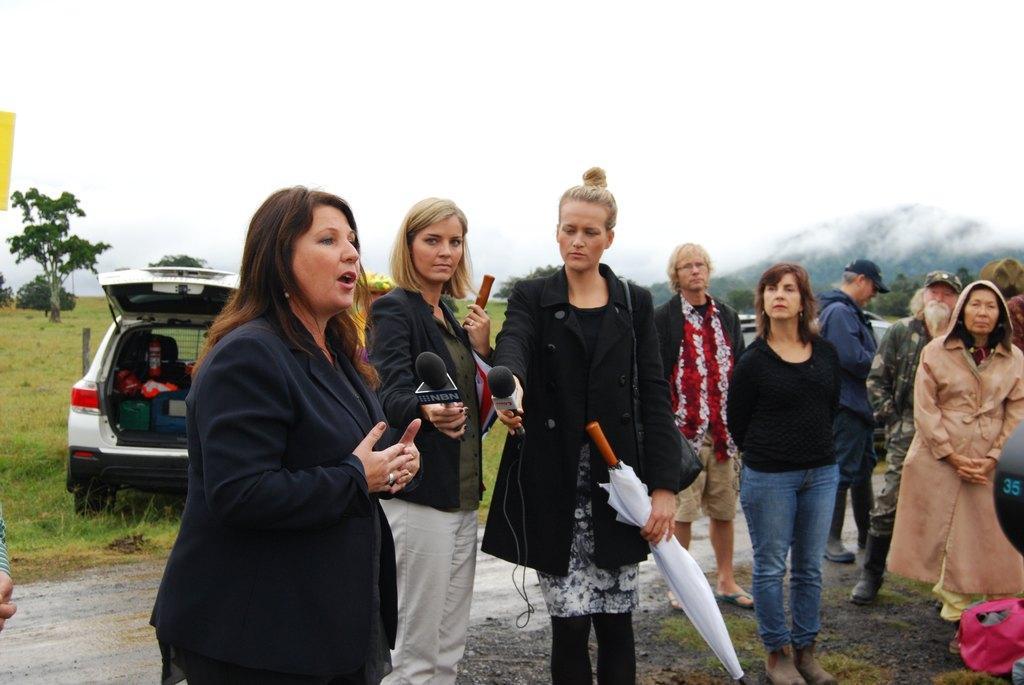In one or two sentences, can you explain what this image depicts? In this picture we can see a group of people on the ground, one woman is holding an umbrella, mic and wearing a bag, another woman is holding a mic, stick, at the back of them we can see vehicles, grass, trees and on one vehicle we can see some objects in it and we can see sky in the background. 